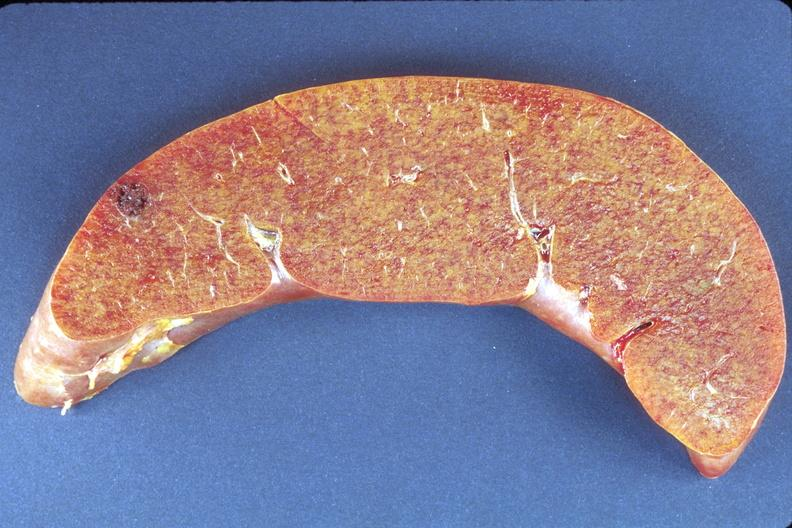what does this image show?
Answer the question using a single word or phrase. Liver 